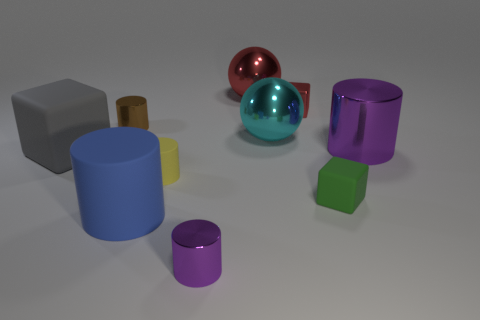Subtract all large gray cubes. How many cubes are left? 2 Add 1 purple objects. How many purple objects are left? 3 Add 1 large gray objects. How many large gray objects exist? 2 Subtract all brown cylinders. How many cylinders are left? 4 Subtract 0 green balls. How many objects are left? 10 Subtract all spheres. How many objects are left? 8 Subtract 1 balls. How many balls are left? 1 Subtract all blue cubes. Subtract all blue spheres. How many cubes are left? 3 Subtract all yellow balls. How many purple cubes are left? 0 Subtract all small brown cylinders. Subtract all green cubes. How many objects are left? 8 